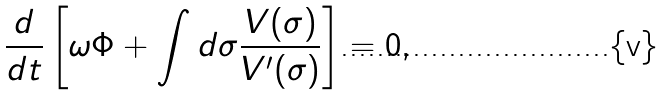Convert formula to latex. <formula><loc_0><loc_0><loc_500><loc_500>\frac { d } { d t } \left [ \omega \Phi + \int d \sigma \frac { V ( \sigma ) } { V ^ { \prime } ( \sigma ) } \right ] = 0 ,</formula> 